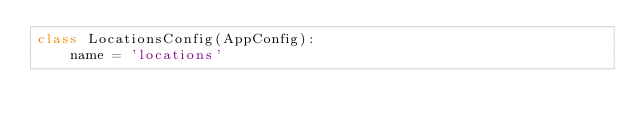<code> <loc_0><loc_0><loc_500><loc_500><_Python_>class LocationsConfig(AppConfig):
    name = 'locations'
</code> 